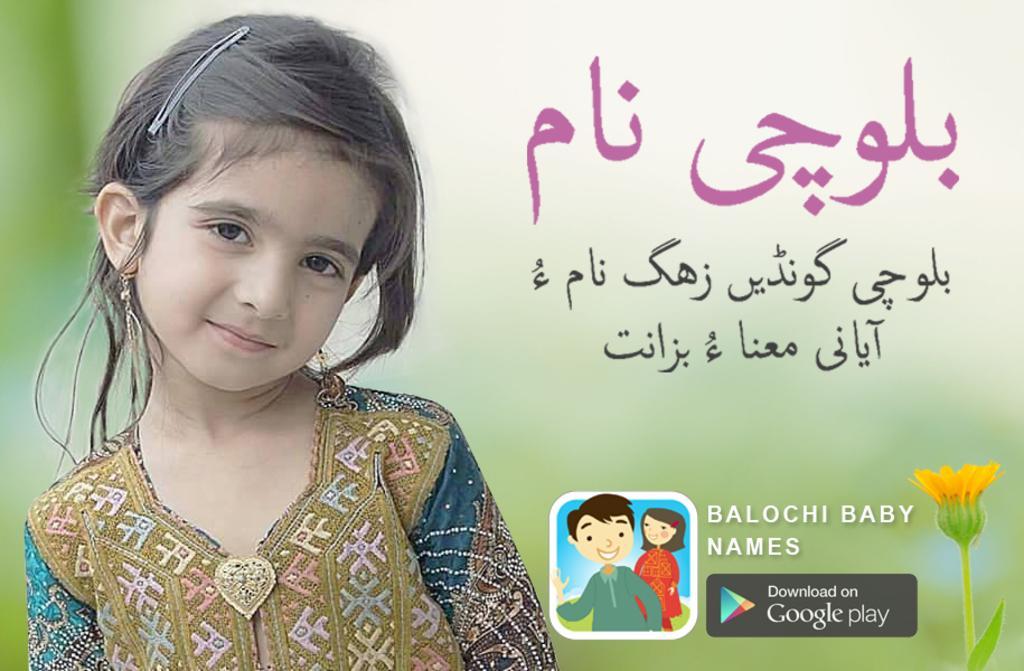Please provide a concise description of this image. In this image in the left side a little cute baby is there, She wore a dress, in the right side there is a flower. In the middle it is an animation. 